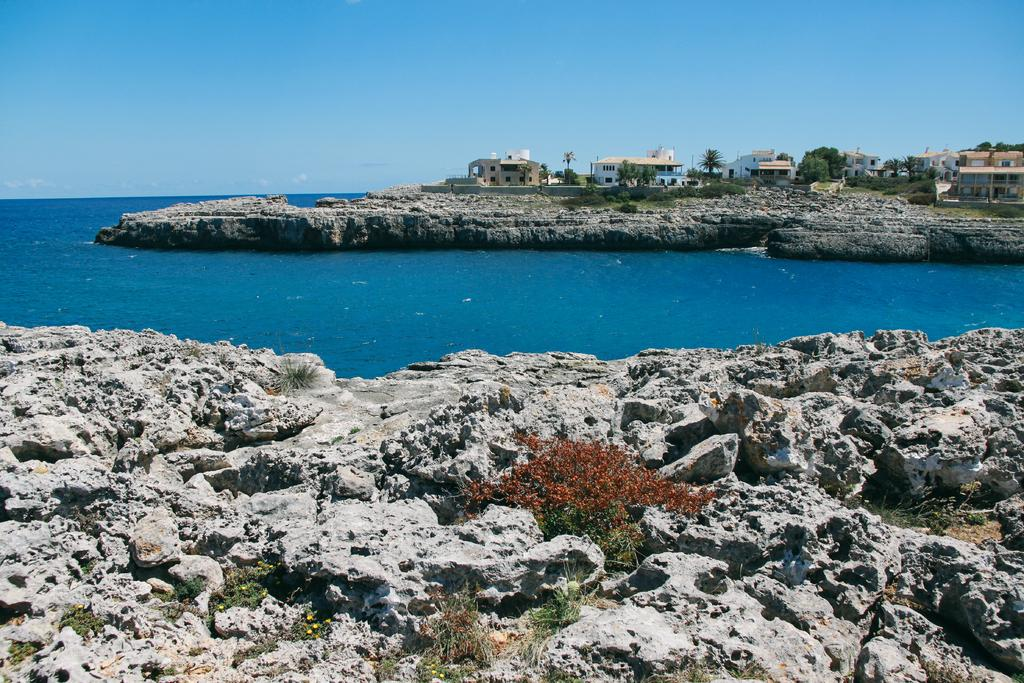What type of natural feature is present in the image? There is an ocean in the image. What structures can be seen on the right side of the image? There are houses on the right side of the image. What is visible in the background of the image? The sky is visible in the background of the image. How does the nose of the person in the image connect to the ocean? There is no person present in the image, so it is not possible to determine how their nose might connect to the ocean. 